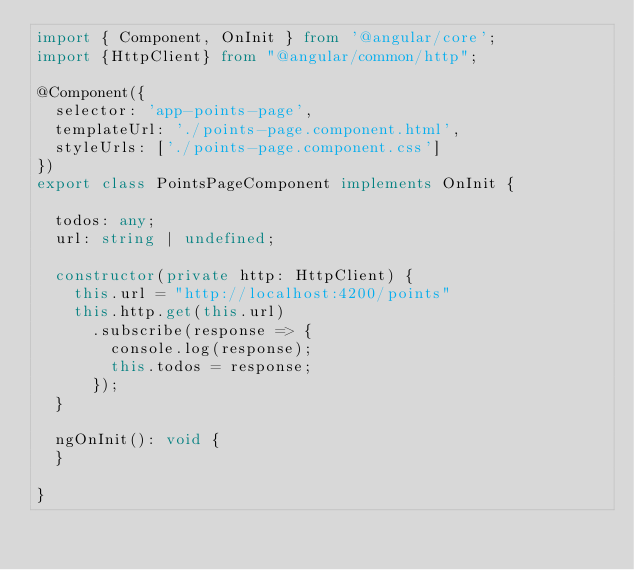Convert code to text. <code><loc_0><loc_0><loc_500><loc_500><_TypeScript_>import { Component, OnInit } from '@angular/core';
import {HttpClient} from "@angular/common/http";

@Component({
  selector: 'app-points-page',
  templateUrl: './points-page.component.html',
  styleUrls: ['./points-page.component.css']
})
export class PointsPageComponent implements OnInit {

  todos: any;
  url: string | undefined;

  constructor(private http: HttpClient) {
    this.url = "http://localhost:4200/points"
    this.http.get(this.url)
      .subscribe(response => {
        console.log(response);
        this.todos = response;
      });
  }

  ngOnInit(): void {
  }

}
</code> 